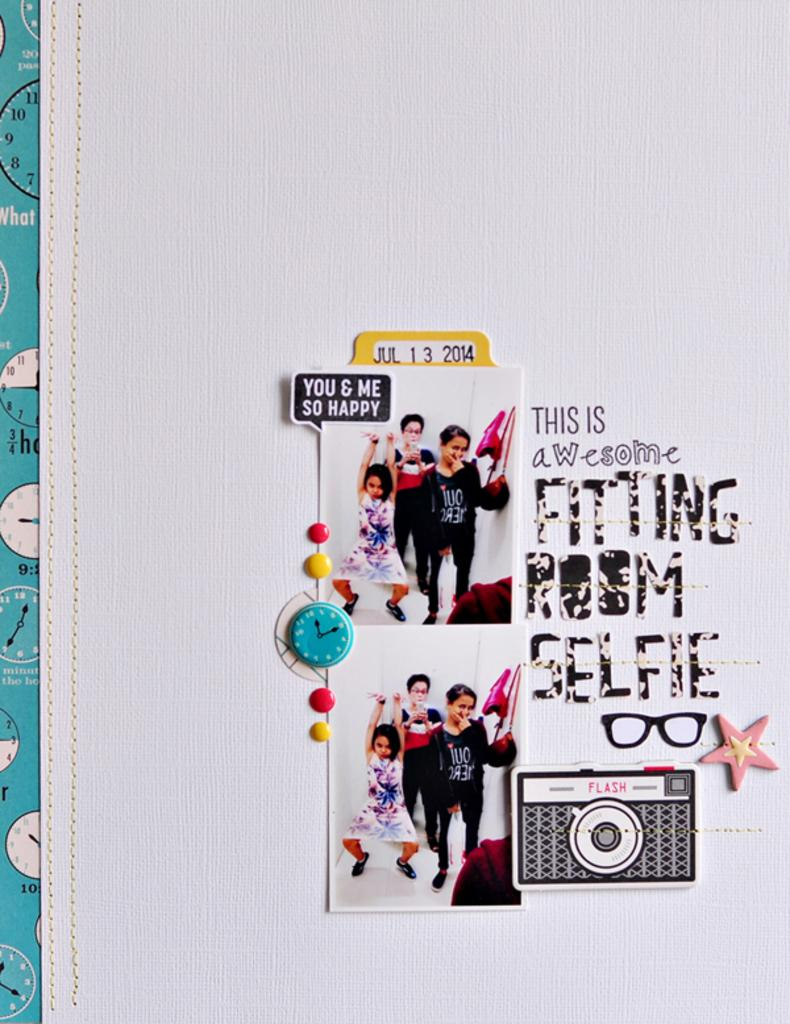Provide a one-sentence caption for the provided image. the year 2014 is on a paper item. 